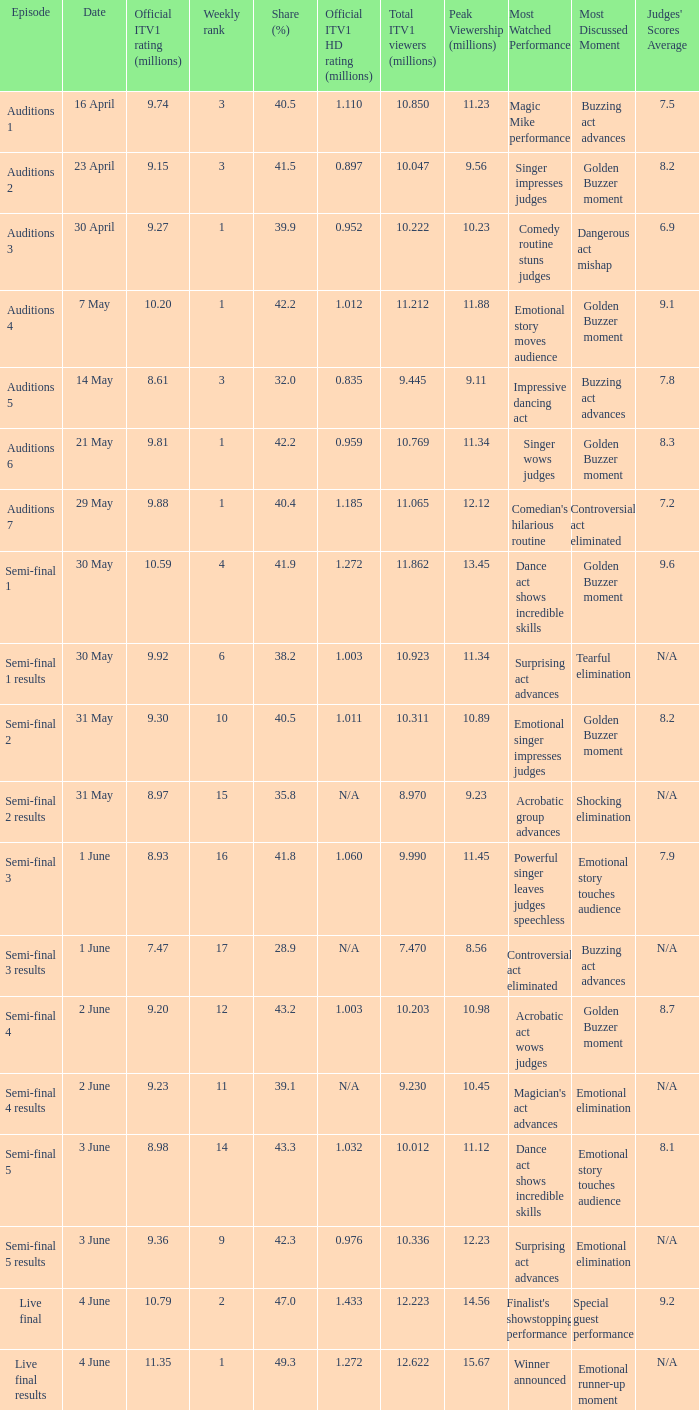When was the episode that had a share (%) of 41.5? 23 April. 